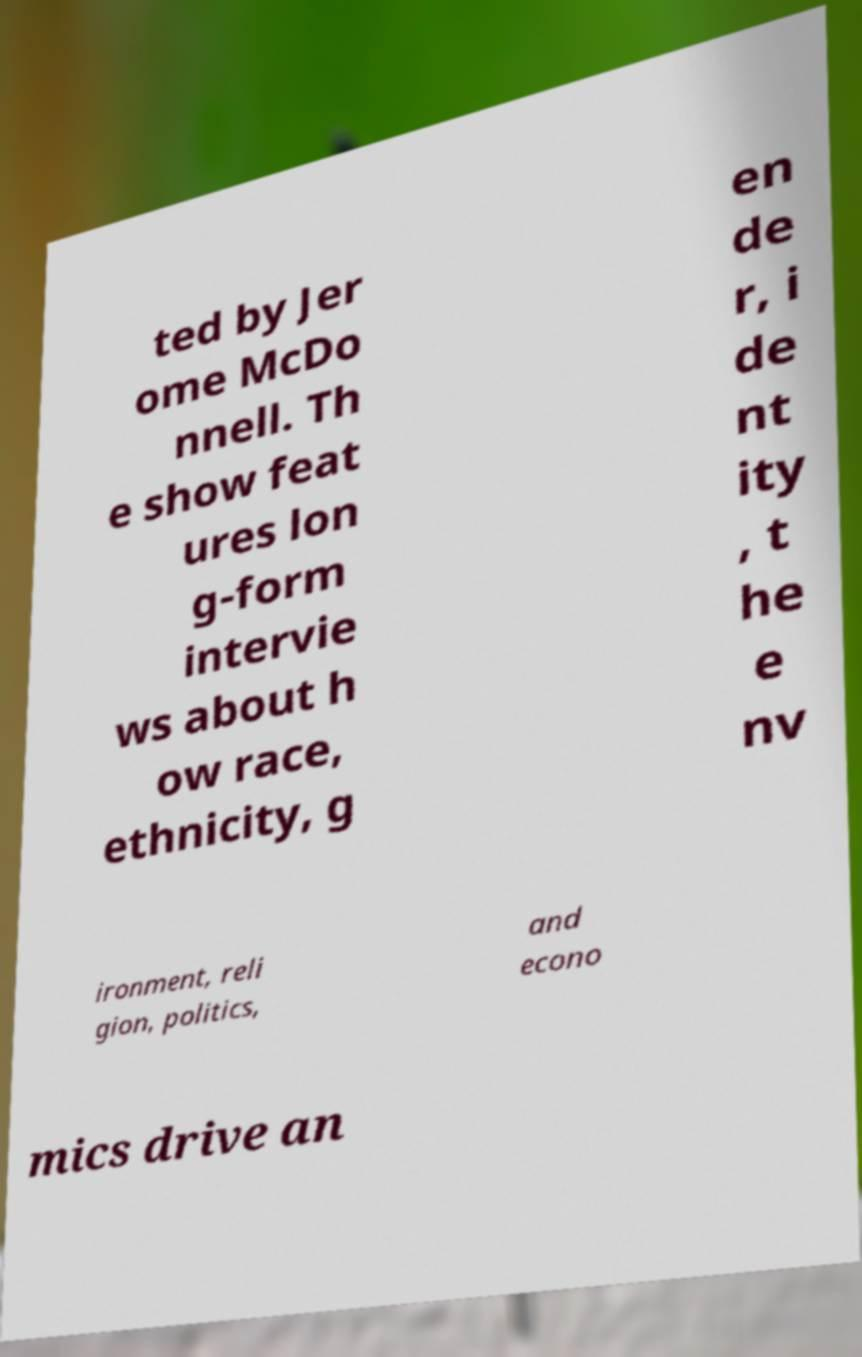Please read and relay the text visible in this image. What does it say? ted by Jer ome McDo nnell. Th e show feat ures lon g-form intervie ws about h ow race, ethnicity, g en de r, i de nt ity , t he e nv ironment, reli gion, politics, and econo mics drive an 